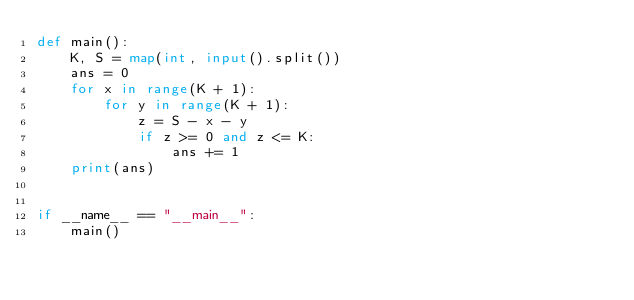Convert code to text. <code><loc_0><loc_0><loc_500><loc_500><_Python_>def main():
    K, S = map(int, input().split())
    ans = 0
    for x in range(K + 1):
        for y in range(K + 1):
            z = S - x - y
            if z >= 0 and z <= K:
                ans += 1
    print(ans)


if __name__ == "__main__":
    main()
</code> 